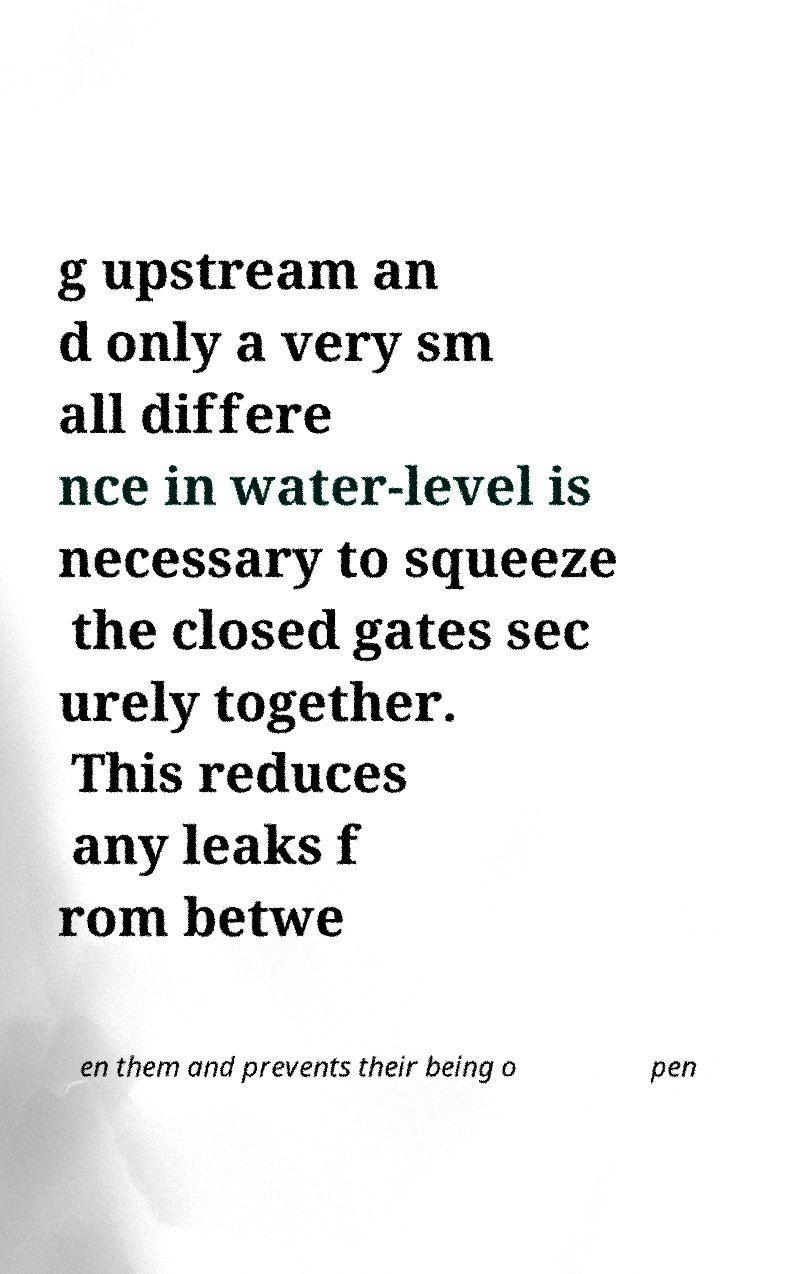Please identify and transcribe the text found in this image. g upstream an d only a very sm all differe nce in water-level is necessary to squeeze the closed gates sec urely together. This reduces any leaks f rom betwe en them and prevents their being o pen 